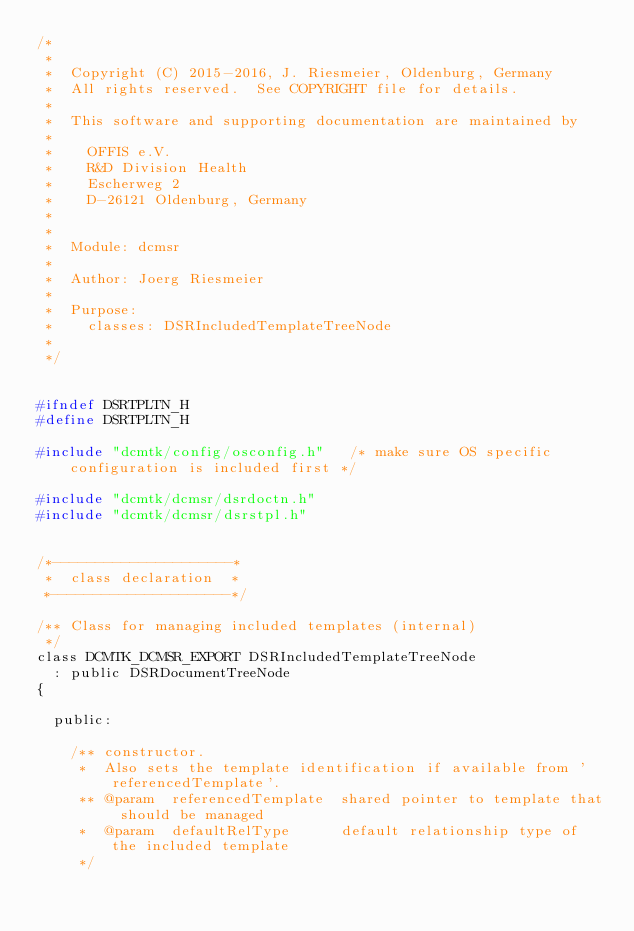<code> <loc_0><loc_0><loc_500><loc_500><_C_>/*
 *
 *  Copyright (C) 2015-2016, J. Riesmeier, Oldenburg, Germany
 *  All rights reserved.  See COPYRIGHT file for details.
 *
 *  This software and supporting documentation are maintained by
 *
 *    OFFIS e.V.
 *    R&D Division Health
 *    Escherweg 2
 *    D-26121 Oldenburg, Germany
 *
 *
 *  Module: dcmsr
 *
 *  Author: Joerg Riesmeier
 *
 *  Purpose:
 *    classes: DSRIncludedTemplateTreeNode
 *
 */


#ifndef DSRTPLTN_H
#define DSRTPLTN_H

#include "dcmtk/config/osconfig.h"   /* make sure OS specific configuration is included first */

#include "dcmtk/dcmsr/dsrdoctn.h"
#include "dcmtk/dcmsr/dsrstpl.h"


/*---------------------*
 *  class declaration  *
 *---------------------*/

/** Class for managing included templates (internal)
 */
class DCMTK_DCMSR_EXPORT DSRIncludedTemplateTreeNode
  : public DSRDocumentTreeNode
{

  public:

    /** constructor.
     *  Also sets the template identification if available from 'referencedTemplate'.
     ** @param  referencedTemplate  shared pointer to template that should be managed
     *  @param  defaultRelType      default relationship type of the included template
     */</code> 